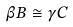Convert formula to latex. <formula><loc_0><loc_0><loc_500><loc_500>\beta B \cong \gamma C</formula> 